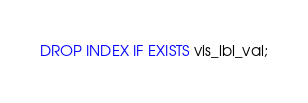<code> <loc_0><loc_0><loc_500><loc_500><_SQL_>DROP INDEX IF EXISTS vis_lbl_val;</code> 